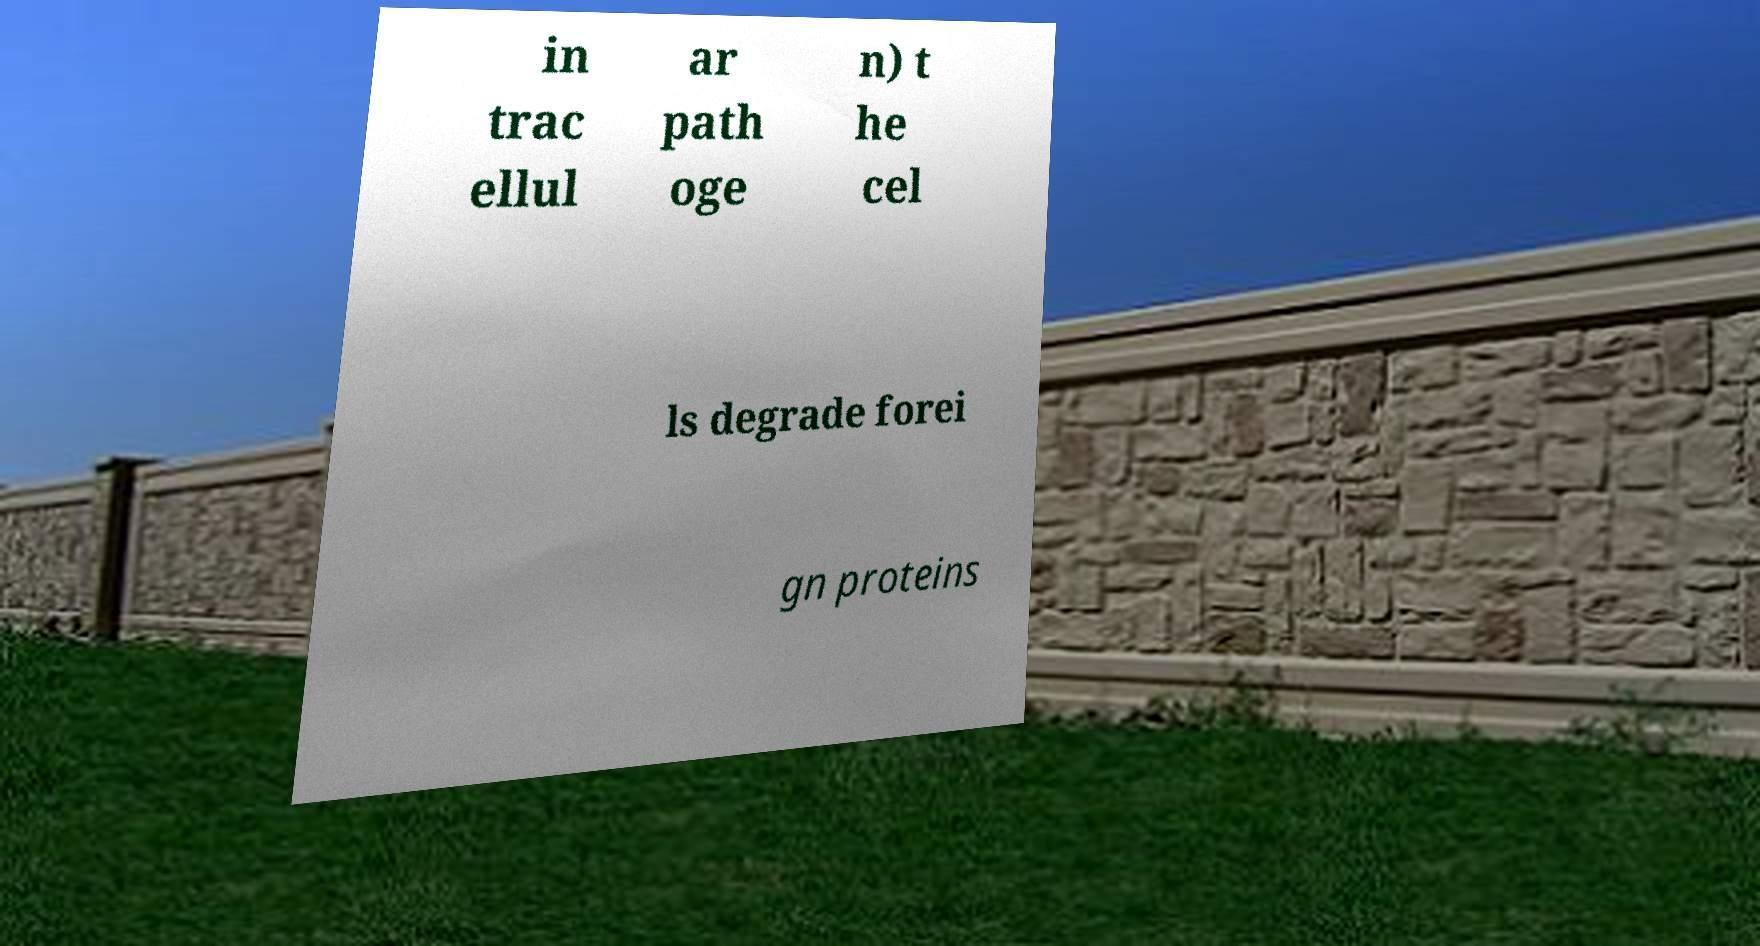There's text embedded in this image that I need extracted. Can you transcribe it verbatim? in trac ellul ar path oge n) t he cel ls degrade forei gn proteins 